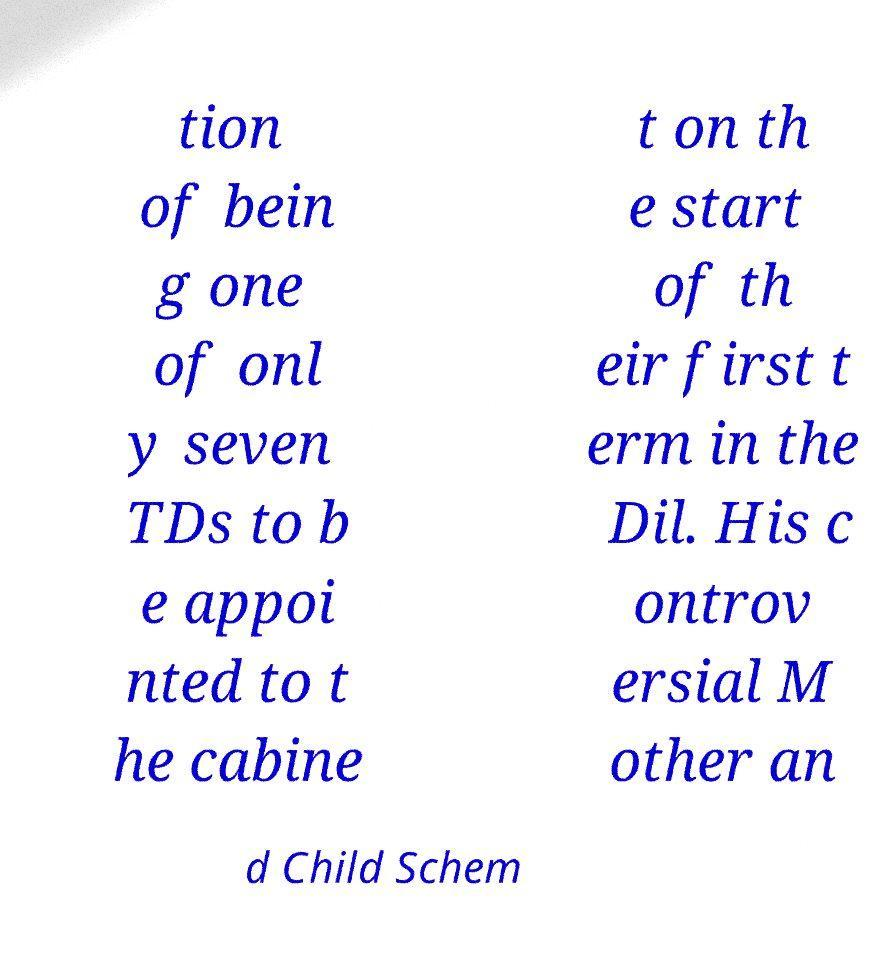Can you accurately transcribe the text from the provided image for me? tion of bein g one of onl y seven TDs to b e appoi nted to t he cabine t on th e start of th eir first t erm in the Dil. His c ontrov ersial M other an d Child Schem 